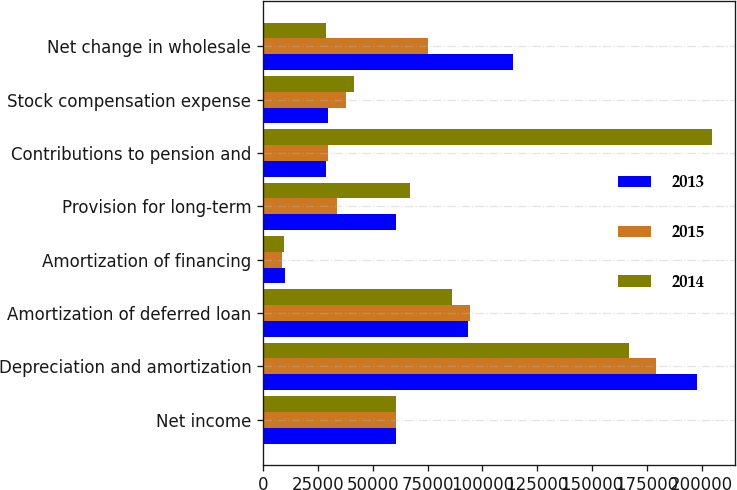Convert chart. <chart><loc_0><loc_0><loc_500><loc_500><stacked_bar_chart><ecel><fcel>Net income<fcel>Depreciation and amortization<fcel>Amortization of deferred loan<fcel>Amortization of financing<fcel>Provision for long-term<fcel>Contributions to pension and<fcel>Stock compensation expense<fcel>Net change in wholesale<nl><fcel>2013<fcel>60824<fcel>198074<fcel>93546<fcel>9975<fcel>60824<fcel>28490<fcel>29433<fcel>113970<nl><fcel>2015<fcel>60824<fcel>179300<fcel>94429<fcel>8442<fcel>33709<fcel>29686<fcel>37929<fcel>75210<nl><fcel>2014<fcel>60824<fcel>167072<fcel>86181<fcel>9376<fcel>66877<fcel>204796<fcel>41244<fcel>28865<nl></chart> 